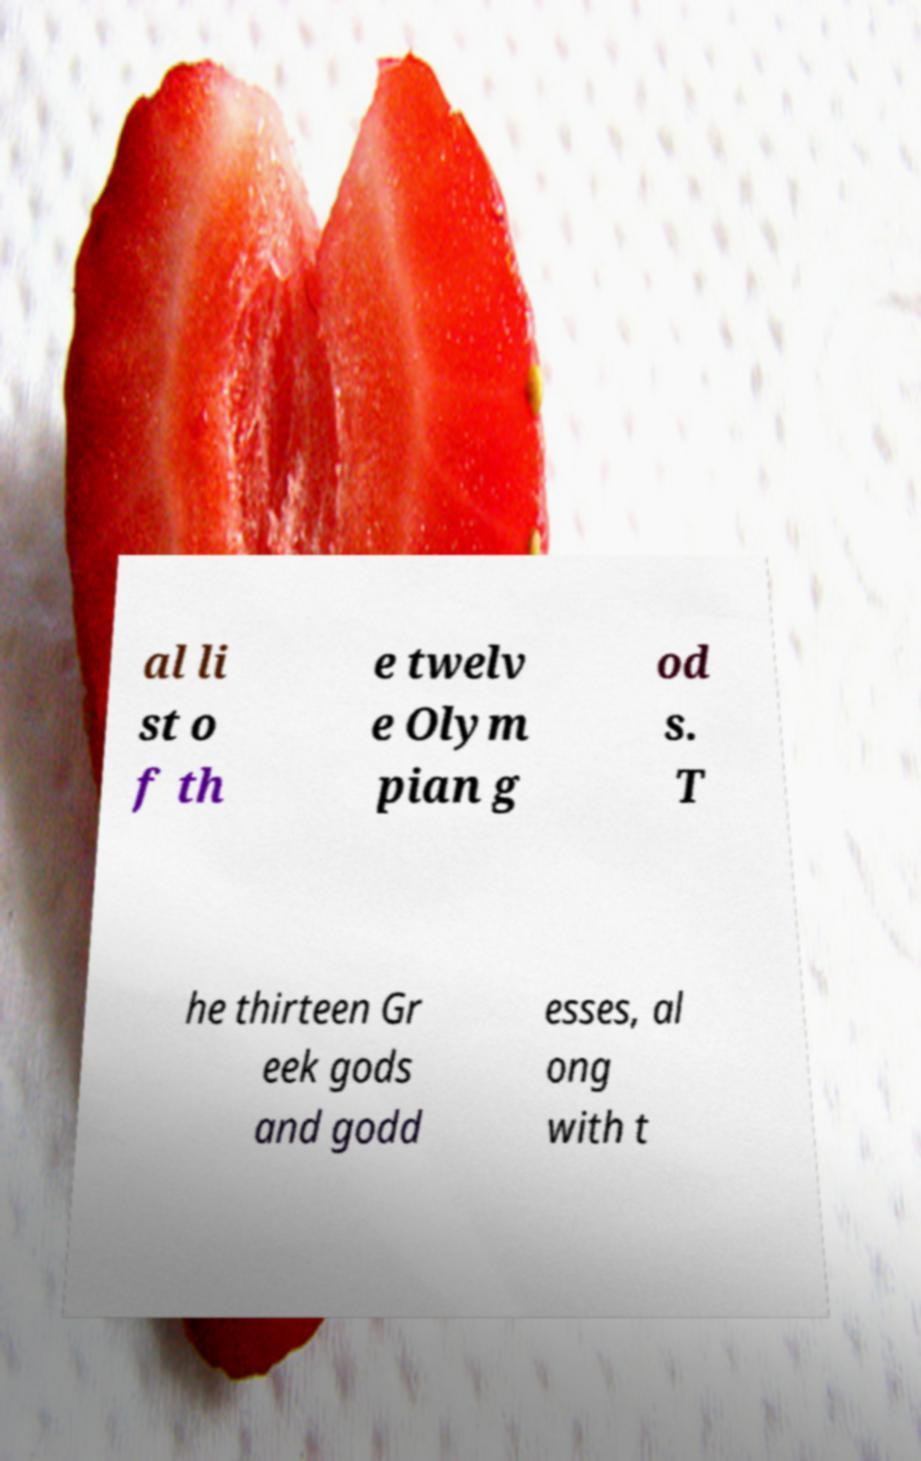Could you extract and type out the text from this image? al li st o f th e twelv e Olym pian g od s. T he thirteen Gr eek gods and godd esses, al ong with t 